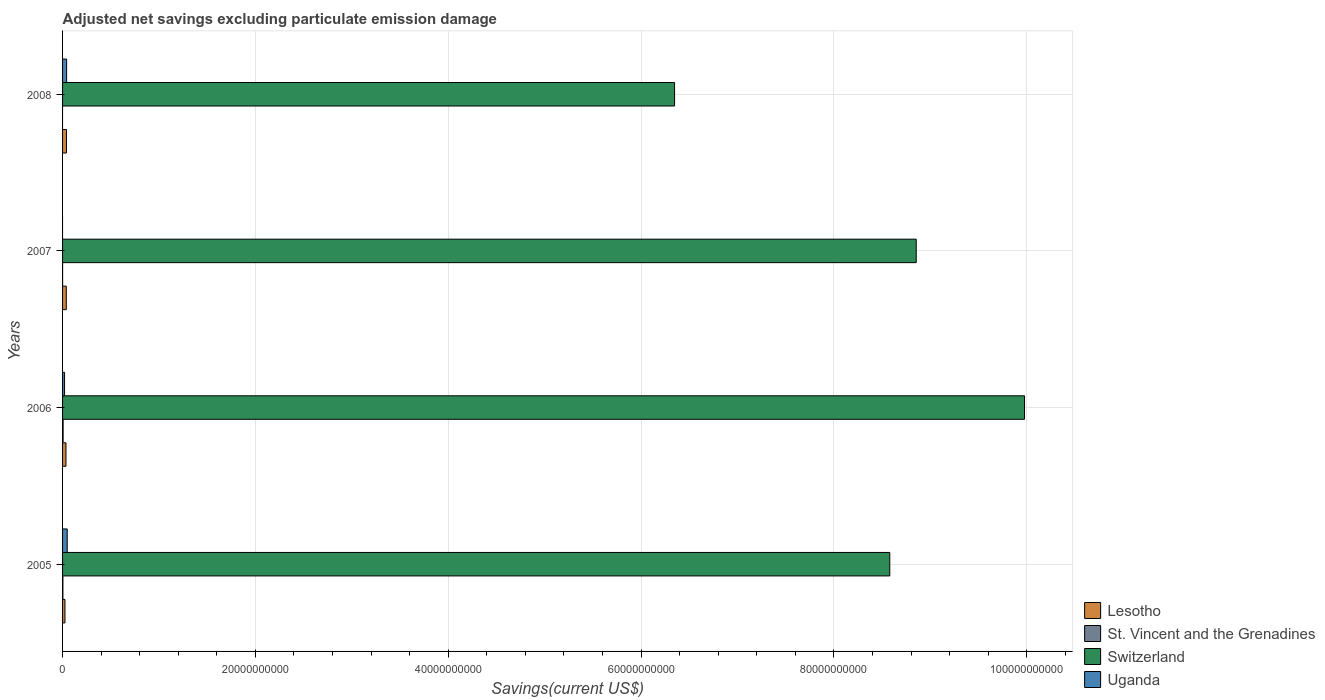Are the number of bars on each tick of the Y-axis equal?
Your response must be concise. No. How many bars are there on the 2nd tick from the bottom?
Ensure brevity in your answer.  4. In how many cases, is the number of bars for a given year not equal to the number of legend labels?
Ensure brevity in your answer.  2. What is the adjusted net savings in Switzerland in 2006?
Provide a succinct answer. 9.98e+1. Across all years, what is the maximum adjusted net savings in St. Vincent and the Grenadines?
Offer a very short reply. 5.70e+07. Across all years, what is the minimum adjusted net savings in St. Vincent and the Grenadines?
Offer a very short reply. 0. What is the total adjusted net savings in Switzerland in the graph?
Your response must be concise. 3.38e+11. What is the difference between the adjusted net savings in Lesotho in 2005 and that in 2006?
Offer a very short reply. -1.04e+08. What is the difference between the adjusted net savings in St. Vincent and the Grenadines in 2006 and the adjusted net savings in Lesotho in 2008?
Your response must be concise. -3.47e+08. What is the average adjusted net savings in Uganda per year?
Provide a short and direct response. 2.78e+08. In the year 2006, what is the difference between the adjusted net savings in Switzerland and adjusted net savings in Lesotho?
Ensure brevity in your answer.  9.94e+1. In how many years, is the adjusted net savings in Lesotho greater than 4000000000 US$?
Give a very brief answer. 0. What is the ratio of the adjusted net savings in Lesotho in 2005 to that in 2008?
Your answer should be compact. 0.62. Is the adjusted net savings in Uganda in 2006 less than that in 2008?
Provide a succinct answer. Yes. What is the difference between the highest and the second highest adjusted net savings in Lesotho?
Offer a very short reply. 1.74e+07. What is the difference between the highest and the lowest adjusted net savings in Lesotho?
Provide a succinct answer. 1.56e+08. In how many years, is the adjusted net savings in Lesotho greater than the average adjusted net savings in Lesotho taken over all years?
Provide a short and direct response. 3. Is the sum of the adjusted net savings in Switzerland in 2005 and 2006 greater than the maximum adjusted net savings in Uganda across all years?
Make the answer very short. Yes. Is it the case that in every year, the sum of the adjusted net savings in Switzerland and adjusted net savings in Lesotho is greater than the sum of adjusted net savings in St. Vincent and the Grenadines and adjusted net savings in Uganda?
Your response must be concise. Yes. Is it the case that in every year, the sum of the adjusted net savings in Uganda and adjusted net savings in Switzerland is greater than the adjusted net savings in Lesotho?
Your answer should be compact. Yes. How many years are there in the graph?
Offer a terse response. 4. What is the difference between two consecutive major ticks on the X-axis?
Provide a succinct answer. 2.00e+1. Does the graph contain any zero values?
Keep it short and to the point. Yes. Does the graph contain grids?
Provide a short and direct response. Yes. Where does the legend appear in the graph?
Offer a terse response. Bottom right. How many legend labels are there?
Provide a short and direct response. 4. How are the legend labels stacked?
Your answer should be very brief. Vertical. What is the title of the graph?
Make the answer very short. Adjusted net savings excluding particulate emission damage. What is the label or title of the X-axis?
Your answer should be very brief. Savings(current US$). What is the label or title of the Y-axis?
Offer a terse response. Years. What is the Savings(current US$) of Lesotho in 2005?
Ensure brevity in your answer.  2.49e+08. What is the Savings(current US$) of St. Vincent and the Grenadines in 2005?
Your response must be concise. 3.38e+07. What is the Savings(current US$) of Switzerland in 2005?
Offer a terse response. 8.58e+1. What is the Savings(current US$) of Uganda in 2005?
Offer a terse response. 4.83e+08. What is the Savings(current US$) in Lesotho in 2006?
Provide a succinct answer. 3.53e+08. What is the Savings(current US$) in St. Vincent and the Grenadines in 2006?
Give a very brief answer. 5.70e+07. What is the Savings(current US$) in Switzerland in 2006?
Your response must be concise. 9.98e+1. What is the Savings(current US$) in Uganda in 2006?
Give a very brief answer. 2.08e+08. What is the Savings(current US$) of Lesotho in 2007?
Make the answer very short. 3.87e+08. What is the Savings(current US$) in St. Vincent and the Grenadines in 2007?
Provide a short and direct response. 5.87e+05. What is the Savings(current US$) of Switzerland in 2007?
Provide a short and direct response. 8.85e+1. What is the Savings(current US$) in Lesotho in 2008?
Provide a short and direct response. 4.04e+08. What is the Savings(current US$) in St. Vincent and the Grenadines in 2008?
Your answer should be very brief. 0. What is the Savings(current US$) in Switzerland in 2008?
Provide a short and direct response. 6.35e+1. What is the Savings(current US$) in Uganda in 2008?
Offer a terse response. 4.21e+08. Across all years, what is the maximum Savings(current US$) in Lesotho?
Your answer should be very brief. 4.04e+08. Across all years, what is the maximum Savings(current US$) in St. Vincent and the Grenadines?
Give a very brief answer. 5.70e+07. Across all years, what is the maximum Savings(current US$) of Switzerland?
Provide a succinct answer. 9.98e+1. Across all years, what is the maximum Savings(current US$) in Uganda?
Offer a very short reply. 4.83e+08. Across all years, what is the minimum Savings(current US$) in Lesotho?
Your answer should be very brief. 2.49e+08. Across all years, what is the minimum Savings(current US$) in St. Vincent and the Grenadines?
Your answer should be compact. 0. Across all years, what is the minimum Savings(current US$) in Switzerland?
Your answer should be very brief. 6.35e+1. Across all years, what is the minimum Savings(current US$) in Uganda?
Provide a succinct answer. 0. What is the total Savings(current US$) in Lesotho in the graph?
Offer a very short reply. 1.39e+09. What is the total Savings(current US$) in St. Vincent and the Grenadines in the graph?
Give a very brief answer. 9.14e+07. What is the total Savings(current US$) in Switzerland in the graph?
Keep it short and to the point. 3.38e+11. What is the total Savings(current US$) in Uganda in the graph?
Your answer should be very brief. 1.11e+09. What is the difference between the Savings(current US$) in Lesotho in 2005 and that in 2006?
Provide a succinct answer. -1.04e+08. What is the difference between the Savings(current US$) of St. Vincent and the Grenadines in 2005 and that in 2006?
Make the answer very short. -2.32e+07. What is the difference between the Savings(current US$) in Switzerland in 2005 and that in 2006?
Ensure brevity in your answer.  -1.40e+1. What is the difference between the Savings(current US$) in Uganda in 2005 and that in 2006?
Give a very brief answer. 2.75e+08. What is the difference between the Savings(current US$) in Lesotho in 2005 and that in 2007?
Offer a terse response. -1.38e+08. What is the difference between the Savings(current US$) in St. Vincent and the Grenadines in 2005 and that in 2007?
Your response must be concise. 3.32e+07. What is the difference between the Savings(current US$) of Switzerland in 2005 and that in 2007?
Provide a succinct answer. -2.74e+09. What is the difference between the Savings(current US$) of Lesotho in 2005 and that in 2008?
Offer a very short reply. -1.56e+08. What is the difference between the Savings(current US$) in Switzerland in 2005 and that in 2008?
Give a very brief answer. 2.23e+1. What is the difference between the Savings(current US$) of Uganda in 2005 and that in 2008?
Offer a terse response. 6.23e+07. What is the difference between the Savings(current US$) of Lesotho in 2006 and that in 2007?
Offer a terse response. -3.38e+07. What is the difference between the Savings(current US$) of St. Vincent and the Grenadines in 2006 and that in 2007?
Provide a short and direct response. 5.64e+07. What is the difference between the Savings(current US$) of Switzerland in 2006 and that in 2007?
Provide a succinct answer. 1.12e+1. What is the difference between the Savings(current US$) of Lesotho in 2006 and that in 2008?
Keep it short and to the point. -5.11e+07. What is the difference between the Savings(current US$) of Switzerland in 2006 and that in 2008?
Your response must be concise. 3.63e+1. What is the difference between the Savings(current US$) in Uganda in 2006 and that in 2008?
Your answer should be very brief. -2.13e+08. What is the difference between the Savings(current US$) in Lesotho in 2007 and that in 2008?
Provide a succinct answer. -1.74e+07. What is the difference between the Savings(current US$) of Switzerland in 2007 and that in 2008?
Offer a terse response. 2.51e+1. What is the difference between the Savings(current US$) of Lesotho in 2005 and the Savings(current US$) of St. Vincent and the Grenadines in 2006?
Your response must be concise. 1.92e+08. What is the difference between the Savings(current US$) of Lesotho in 2005 and the Savings(current US$) of Switzerland in 2006?
Your answer should be compact. -9.95e+1. What is the difference between the Savings(current US$) in Lesotho in 2005 and the Savings(current US$) in Uganda in 2006?
Give a very brief answer. 4.10e+07. What is the difference between the Savings(current US$) of St. Vincent and the Grenadines in 2005 and the Savings(current US$) of Switzerland in 2006?
Your answer should be very brief. -9.97e+1. What is the difference between the Savings(current US$) in St. Vincent and the Grenadines in 2005 and the Savings(current US$) in Uganda in 2006?
Ensure brevity in your answer.  -1.74e+08. What is the difference between the Savings(current US$) in Switzerland in 2005 and the Savings(current US$) in Uganda in 2006?
Give a very brief answer. 8.56e+1. What is the difference between the Savings(current US$) in Lesotho in 2005 and the Savings(current US$) in St. Vincent and the Grenadines in 2007?
Ensure brevity in your answer.  2.48e+08. What is the difference between the Savings(current US$) in Lesotho in 2005 and the Savings(current US$) in Switzerland in 2007?
Keep it short and to the point. -8.83e+1. What is the difference between the Savings(current US$) in St. Vincent and the Grenadines in 2005 and the Savings(current US$) in Switzerland in 2007?
Keep it short and to the point. -8.85e+1. What is the difference between the Savings(current US$) in Lesotho in 2005 and the Savings(current US$) in Switzerland in 2008?
Your response must be concise. -6.32e+1. What is the difference between the Savings(current US$) of Lesotho in 2005 and the Savings(current US$) of Uganda in 2008?
Offer a very short reply. -1.72e+08. What is the difference between the Savings(current US$) in St. Vincent and the Grenadines in 2005 and the Savings(current US$) in Switzerland in 2008?
Give a very brief answer. -6.34e+1. What is the difference between the Savings(current US$) of St. Vincent and the Grenadines in 2005 and the Savings(current US$) of Uganda in 2008?
Offer a terse response. -3.87e+08. What is the difference between the Savings(current US$) in Switzerland in 2005 and the Savings(current US$) in Uganda in 2008?
Offer a very short reply. 8.54e+1. What is the difference between the Savings(current US$) of Lesotho in 2006 and the Savings(current US$) of St. Vincent and the Grenadines in 2007?
Offer a terse response. 3.52e+08. What is the difference between the Savings(current US$) of Lesotho in 2006 and the Savings(current US$) of Switzerland in 2007?
Provide a short and direct response. -8.82e+1. What is the difference between the Savings(current US$) in St. Vincent and the Grenadines in 2006 and the Savings(current US$) in Switzerland in 2007?
Provide a short and direct response. -8.85e+1. What is the difference between the Savings(current US$) of Lesotho in 2006 and the Savings(current US$) of Switzerland in 2008?
Make the answer very short. -6.31e+1. What is the difference between the Savings(current US$) of Lesotho in 2006 and the Savings(current US$) of Uganda in 2008?
Ensure brevity in your answer.  -6.77e+07. What is the difference between the Savings(current US$) of St. Vincent and the Grenadines in 2006 and the Savings(current US$) of Switzerland in 2008?
Your answer should be compact. -6.34e+1. What is the difference between the Savings(current US$) in St. Vincent and the Grenadines in 2006 and the Savings(current US$) in Uganda in 2008?
Offer a very short reply. -3.64e+08. What is the difference between the Savings(current US$) of Switzerland in 2006 and the Savings(current US$) of Uganda in 2008?
Your answer should be very brief. 9.94e+1. What is the difference between the Savings(current US$) in Lesotho in 2007 and the Savings(current US$) in Switzerland in 2008?
Your response must be concise. -6.31e+1. What is the difference between the Savings(current US$) of Lesotho in 2007 and the Savings(current US$) of Uganda in 2008?
Keep it short and to the point. -3.39e+07. What is the difference between the Savings(current US$) in St. Vincent and the Grenadines in 2007 and the Savings(current US$) in Switzerland in 2008?
Offer a very short reply. -6.35e+1. What is the difference between the Savings(current US$) in St. Vincent and the Grenadines in 2007 and the Savings(current US$) in Uganda in 2008?
Ensure brevity in your answer.  -4.20e+08. What is the difference between the Savings(current US$) of Switzerland in 2007 and the Savings(current US$) of Uganda in 2008?
Your answer should be compact. 8.81e+1. What is the average Savings(current US$) in Lesotho per year?
Your answer should be compact. 3.48e+08. What is the average Savings(current US$) of St. Vincent and the Grenadines per year?
Your response must be concise. 2.28e+07. What is the average Savings(current US$) of Switzerland per year?
Ensure brevity in your answer.  8.44e+1. What is the average Savings(current US$) in Uganda per year?
Provide a short and direct response. 2.78e+08. In the year 2005, what is the difference between the Savings(current US$) in Lesotho and Savings(current US$) in St. Vincent and the Grenadines?
Your answer should be very brief. 2.15e+08. In the year 2005, what is the difference between the Savings(current US$) of Lesotho and Savings(current US$) of Switzerland?
Make the answer very short. -8.55e+1. In the year 2005, what is the difference between the Savings(current US$) of Lesotho and Savings(current US$) of Uganda?
Provide a short and direct response. -2.34e+08. In the year 2005, what is the difference between the Savings(current US$) in St. Vincent and the Grenadines and Savings(current US$) in Switzerland?
Ensure brevity in your answer.  -8.58e+1. In the year 2005, what is the difference between the Savings(current US$) of St. Vincent and the Grenadines and Savings(current US$) of Uganda?
Provide a short and direct response. -4.49e+08. In the year 2005, what is the difference between the Savings(current US$) of Switzerland and Savings(current US$) of Uganda?
Give a very brief answer. 8.53e+1. In the year 2006, what is the difference between the Savings(current US$) of Lesotho and Savings(current US$) of St. Vincent and the Grenadines?
Provide a succinct answer. 2.96e+08. In the year 2006, what is the difference between the Savings(current US$) in Lesotho and Savings(current US$) in Switzerland?
Make the answer very short. -9.94e+1. In the year 2006, what is the difference between the Savings(current US$) in Lesotho and Savings(current US$) in Uganda?
Offer a very short reply. 1.45e+08. In the year 2006, what is the difference between the Savings(current US$) of St. Vincent and the Grenadines and Savings(current US$) of Switzerland?
Keep it short and to the point. -9.97e+1. In the year 2006, what is the difference between the Savings(current US$) of St. Vincent and the Grenadines and Savings(current US$) of Uganda?
Your answer should be compact. -1.51e+08. In the year 2006, what is the difference between the Savings(current US$) of Switzerland and Savings(current US$) of Uganda?
Provide a succinct answer. 9.96e+1. In the year 2007, what is the difference between the Savings(current US$) in Lesotho and Savings(current US$) in St. Vincent and the Grenadines?
Make the answer very short. 3.86e+08. In the year 2007, what is the difference between the Savings(current US$) of Lesotho and Savings(current US$) of Switzerland?
Provide a short and direct response. -8.82e+1. In the year 2007, what is the difference between the Savings(current US$) of St. Vincent and the Grenadines and Savings(current US$) of Switzerland?
Make the answer very short. -8.85e+1. In the year 2008, what is the difference between the Savings(current US$) of Lesotho and Savings(current US$) of Switzerland?
Keep it short and to the point. -6.31e+1. In the year 2008, what is the difference between the Savings(current US$) in Lesotho and Savings(current US$) in Uganda?
Your answer should be compact. -1.66e+07. In the year 2008, what is the difference between the Savings(current US$) of Switzerland and Savings(current US$) of Uganda?
Keep it short and to the point. 6.31e+1. What is the ratio of the Savings(current US$) of Lesotho in 2005 to that in 2006?
Your answer should be very brief. 0.7. What is the ratio of the Savings(current US$) of St. Vincent and the Grenadines in 2005 to that in 2006?
Ensure brevity in your answer.  0.59. What is the ratio of the Savings(current US$) of Switzerland in 2005 to that in 2006?
Your answer should be compact. 0.86. What is the ratio of the Savings(current US$) in Uganda in 2005 to that in 2006?
Provide a short and direct response. 2.33. What is the ratio of the Savings(current US$) of Lesotho in 2005 to that in 2007?
Your answer should be very brief. 0.64. What is the ratio of the Savings(current US$) of St. Vincent and the Grenadines in 2005 to that in 2007?
Keep it short and to the point. 57.54. What is the ratio of the Savings(current US$) in Switzerland in 2005 to that in 2007?
Offer a terse response. 0.97. What is the ratio of the Savings(current US$) in Lesotho in 2005 to that in 2008?
Provide a succinct answer. 0.62. What is the ratio of the Savings(current US$) of Switzerland in 2005 to that in 2008?
Your answer should be very brief. 1.35. What is the ratio of the Savings(current US$) of Uganda in 2005 to that in 2008?
Keep it short and to the point. 1.15. What is the ratio of the Savings(current US$) in Lesotho in 2006 to that in 2007?
Make the answer very short. 0.91. What is the ratio of the Savings(current US$) in St. Vincent and the Grenadines in 2006 to that in 2007?
Provide a short and direct response. 97.04. What is the ratio of the Savings(current US$) in Switzerland in 2006 to that in 2007?
Keep it short and to the point. 1.13. What is the ratio of the Savings(current US$) in Lesotho in 2006 to that in 2008?
Your answer should be compact. 0.87. What is the ratio of the Savings(current US$) of Switzerland in 2006 to that in 2008?
Provide a succinct answer. 1.57. What is the ratio of the Savings(current US$) of Uganda in 2006 to that in 2008?
Give a very brief answer. 0.49. What is the ratio of the Savings(current US$) in Switzerland in 2007 to that in 2008?
Give a very brief answer. 1.39. What is the difference between the highest and the second highest Savings(current US$) in Lesotho?
Your response must be concise. 1.74e+07. What is the difference between the highest and the second highest Savings(current US$) in St. Vincent and the Grenadines?
Offer a terse response. 2.32e+07. What is the difference between the highest and the second highest Savings(current US$) of Switzerland?
Your answer should be compact. 1.12e+1. What is the difference between the highest and the second highest Savings(current US$) in Uganda?
Your answer should be compact. 6.23e+07. What is the difference between the highest and the lowest Savings(current US$) in Lesotho?
Offer a very short reply. 1.56e+08. What is the difference between the highest and the lowest Savings(current US$) in St. Vincent and the Grenadines?
Keep it short and to the point. 5.70e+07. What is the difference between the highest and the lowest Savings(current US$) of Switzerland?
Offer a very short reply. 3.63e+1. What is the difference between the highest and the lowest Savings(current US$) in Uganda?
Make the answer very short. 4.83e+08. 